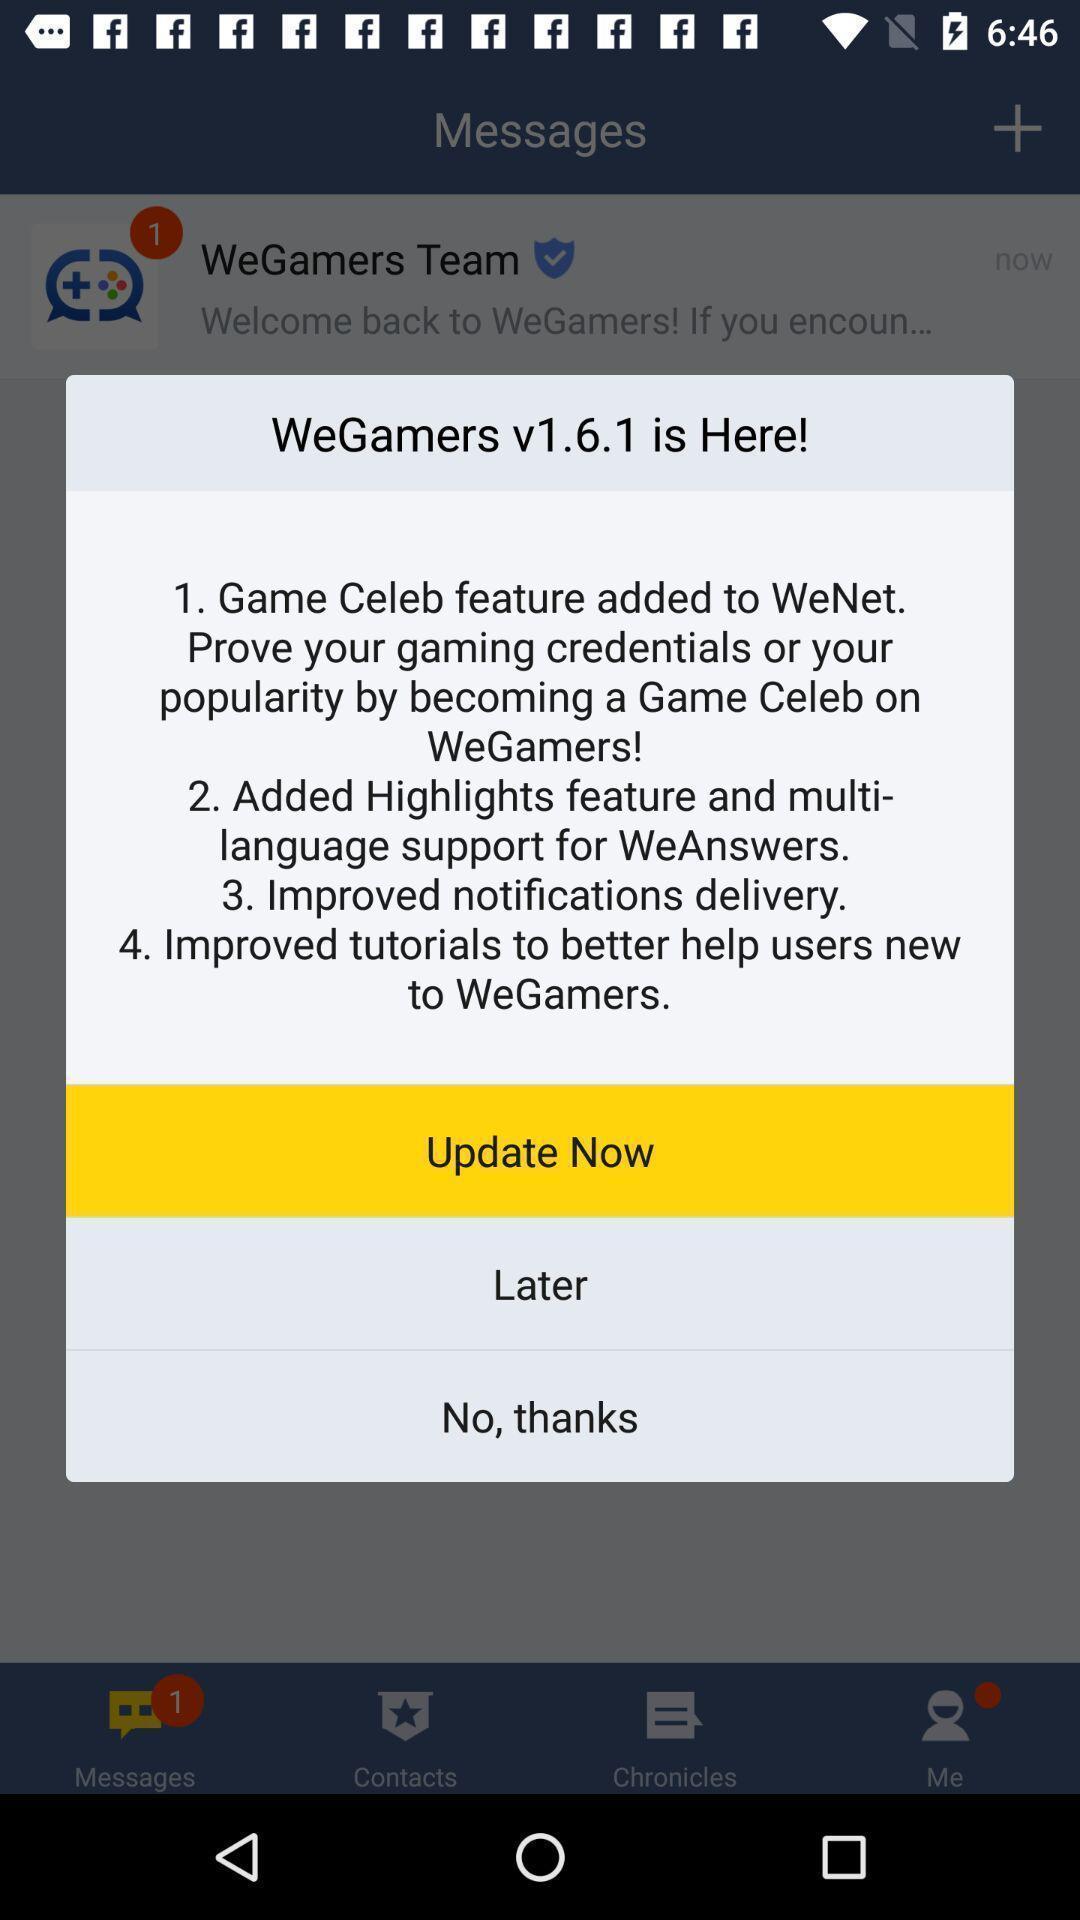Describe the visual elements of this screenshot. Pop-up showing the update notification. 